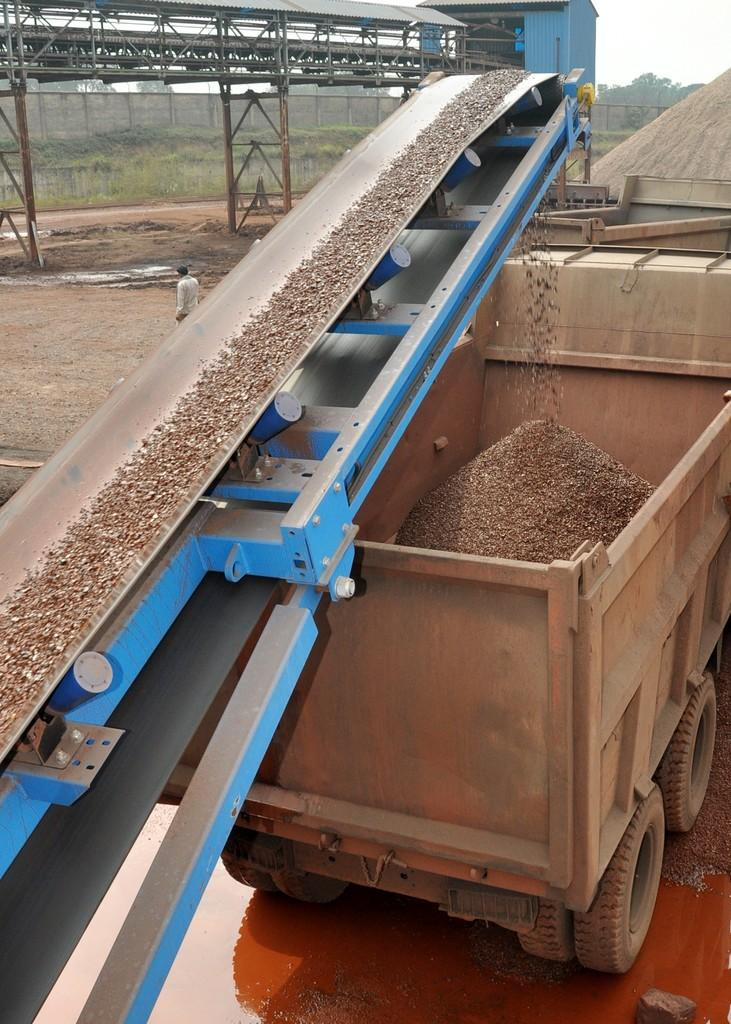What type of vehicle is in the image? There is a truck in the image. What is at the bottom of the image? There is mud at the bottom of the image. What other machinery can be seen in the image? There is a machine in the image. What can be seen in the background of the image? Trees and plants are visible in the background of the image. What type of structure is in the image? There is a shed in the image. What are the long, thin objects in the image? Rods are present in the image. Who is in the image? There is a person in the image. What part of the natural environment is visible in the image? The sky is visible in the background of the image. How does the person in the image fold the trees in half? There is no indication in the image that the person is folding trees or that the trees can be folded. 